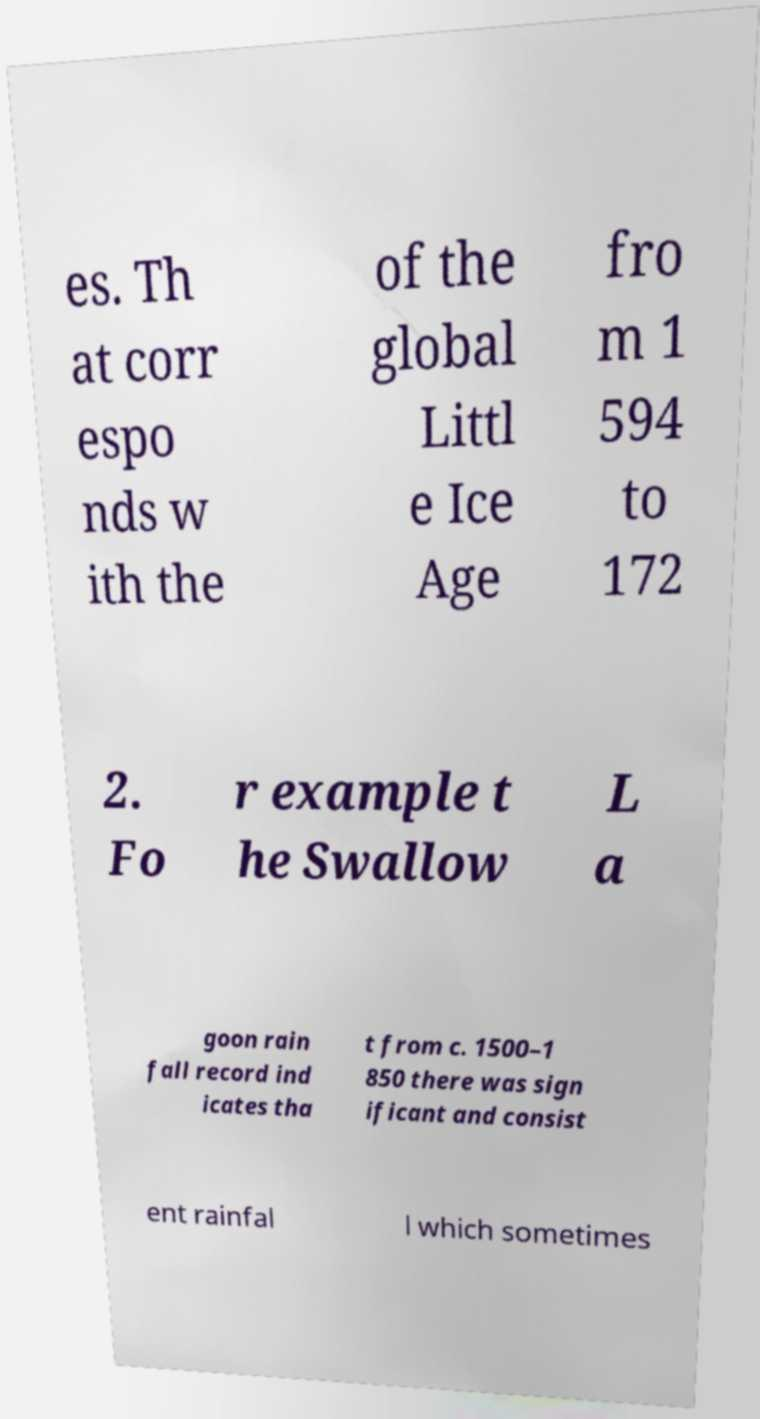Please identify and transcribe the text found in this image. es. Th at corr espo nds w ith the of the global Littl e Ice Age fro m 1 594 to 172 2. Fo r example t he Swallow L a goon rain fall record ind icates tha t from c. 1500–1 850 there was sign ificant and consist ent rainfal l which sometimes 